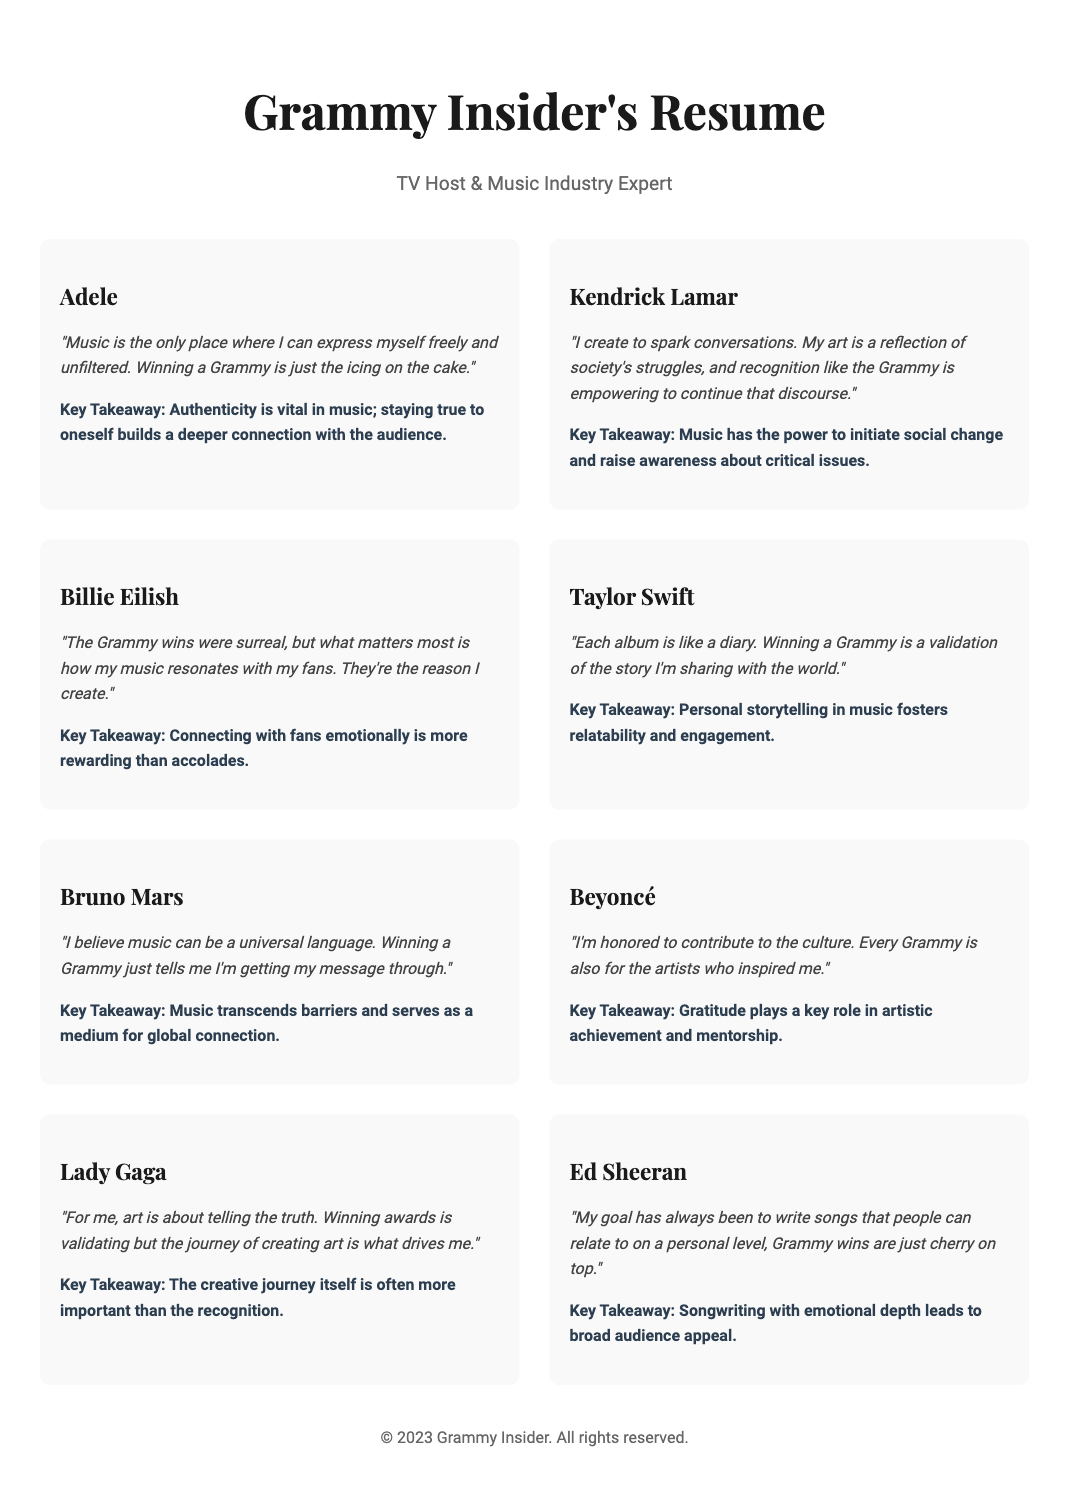What is the title of the document? The title of the document is the heading of the main section showcasing the host's achievements in interviews with Grammy Award winners.
Answer: Grammy Insider's Resume Who is quoted saying, "Music is the only place where I can express myself freely and unfiltered"? This question asks for the artist associated with the provided quote in the document.
Answer: Adele What does Taylor Swift compare each album to? This question seeks a comparative metaphor used in the document regarding Taylor Swift's albums.
Answer: A diary How many artist highlights are included in the document? This question is based on counting the number of distinct artist highlight sections in the document.
Answer: Eight What is the key takeaway from Beyoncé's quote? The key takeaway summarizes the central idea conveyed in Beyoncé's highlighted section.
Answer: Gratitude plays a key role in artistic achievement and mentorship Who mentioned that "the creative journey itself is often more important than the recognition"? This question identifies the artist associated with the notion of the creative journey.
Answer: Lady Gaga What kind of document is this? The document showcases achievements and insights, specifically arranged in a format typical for showcasing credentials.
Answer: Resume Which artist cites their music as a reflection of society's struggles? This question seeks to identify the artist connected with social commentary through their work.
Answer: Kendrick Lamar 